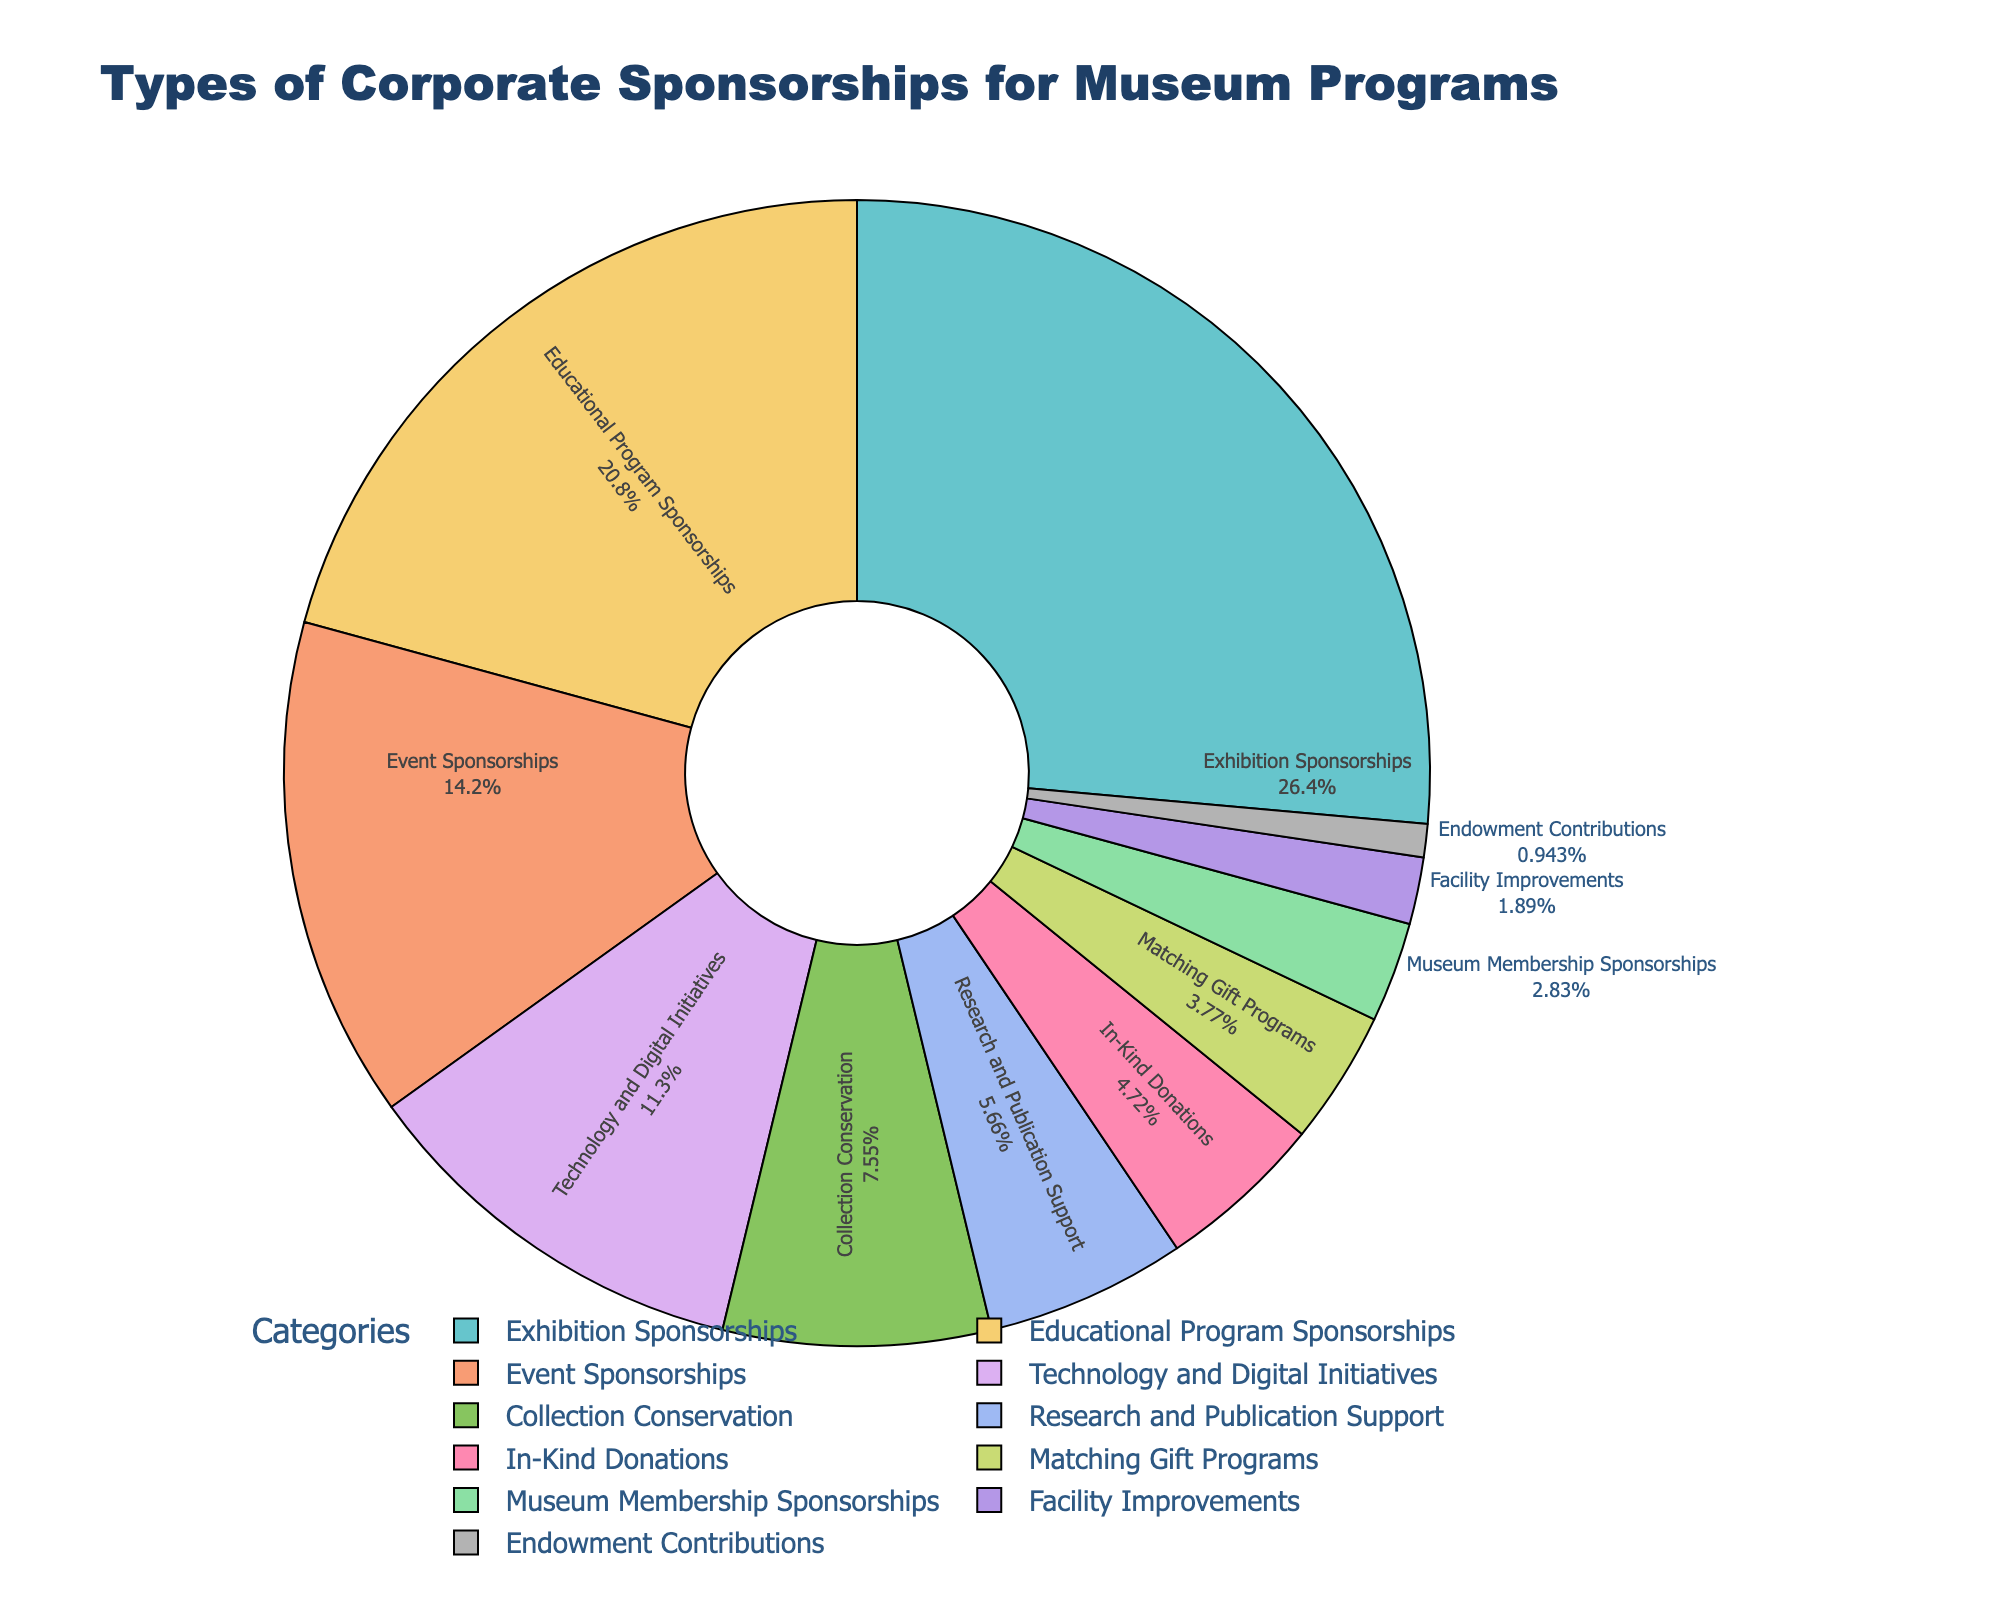Which category secures the highest percentage of sponsorships? The pie chart shows that "Exhibition Sponsorships" secures the highest percentage at 28%.
Answer: Exhibition Sponsorships What is the combined percentage of sponsorships for "Technology and Digital Initiatives" and "Collection Conservation"? Adding the percentages for both categories: 12% for Technology and Digital Initiatives and 8% for Collection Conservation, which sums up to 20%.
Answer: 20% How does the percentage for "Event Sponsorships" compare to "Educational Program Sponsorships"? The pie chart reveals that Event Sponsorships are at 15%, while Educational Program Sponsorships are at 22%. Therefore, Educational Program Sponsorships have a higher percentage.
Answer: Educational Program Sponsorships have a higher percentage What is the difference in percentage between the highest and the lowest sponsorship categories? The highest percentage is for Exhibition Sponsorships at 28%, and the lowest is Endowment Contributions at 1%. The difference is 28% - 1% = 27%.
Answer: 27% Which categories together secure more than 50% of the total sponsorship? Summing up the top categories: Exhibition Sponsorships (28%), Educational Program Sponsorships (22%), and Event Sponsorships (15%) add up to 28% + 22% + 15% = 65%.
Answer: Exhibition Sponsorships, Educational Program Sponsorships, Event Sponsorships How do “Matching Gift Programs” and “Museum Membership Sponsorships” compare visually in terms of segment size? The pie chart shows that Matching Gift Programs have a percentage of 4%, while Museum Membership Sponsorships have 3%. The segment for Matching Gift Programs is visually larger.
Answer: Matching Gift Programs Which types of sponsorships combined equal the percentage for "Event Sponsorships"? The "Event Sponsorships" category is at 15%. Summing percentages for "Collection Conservation" (8%) and "Research and Publication Support" (6%) gives us 8% + 6% = 14%. Adding "In-Kind Donations" at 5% achieves 14% + 5% = 19%. So, "Collection Conservation" and "Research and Publication Support" combined (but not exactly the same) is closest.
Answer: Collection Conservation and Research and Publication Support are closest What is the second least common type of sponsorship? The pie chart shows the least common type is Endowment Contributions at 1%, followed by Facility Improvements at 2%.
Answer: Facility Improvements What visual features help identify the most prominent category on the pie chart? The largest segment belongs to "Exhibition Sponsorships" at 28% and the segment extends the furthest radially compared to others. The label and percentage displayed inside the segment are also prominent.
Answer: Largest segment, extends radially What is the sum of the percentages for the three categories with the lowest sponsorship? The categories with the lowest percentages are Endowment Contributions (1%), Facility Improvements (2%), and Museum Membership Sponsorships (3%). Adding these: 1% + 2% + 3% = 6%.
Answer: 6% 